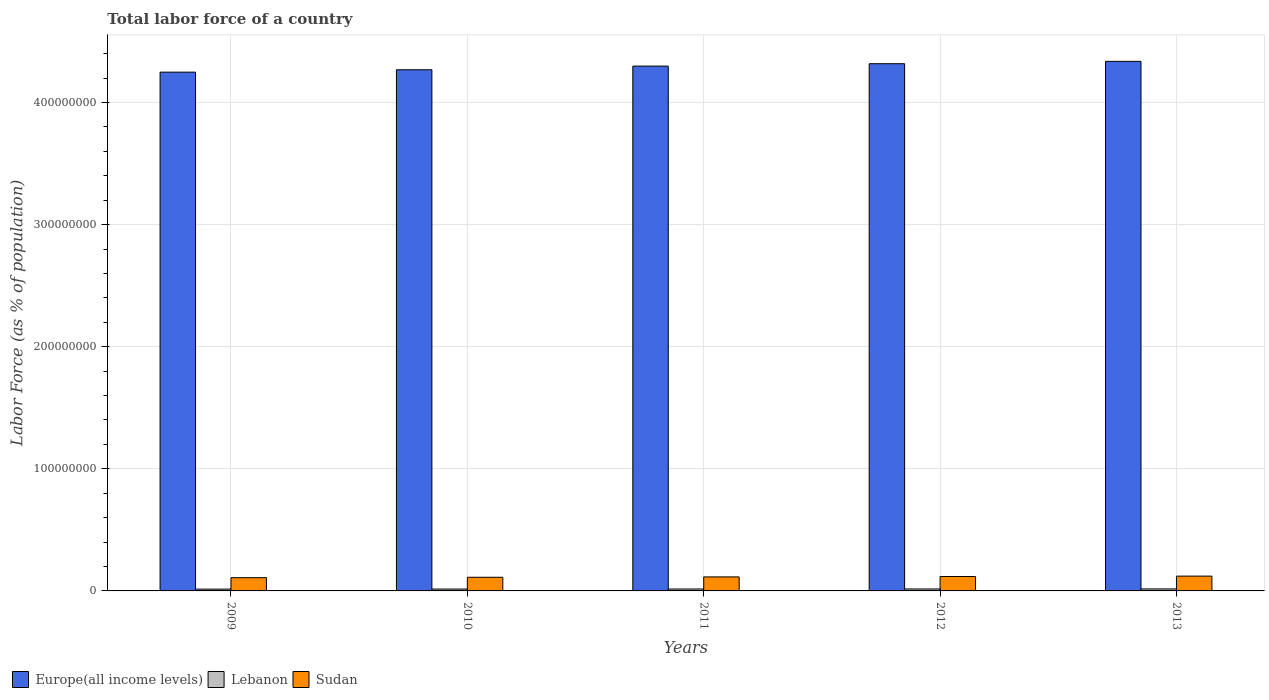Are the number of bars per tick equal to the number of legend labels?
Make the answer very short. Yes. What is the percentage of labor force in Lebanon in 2011?
Provide a short and direct response. 1.57e+06. Across all years, what is the maximum percentage of labor force in Europe(all income levels)?
Offer a very short reply. 4.34e+08. Across all years, what is the minimum percentage of labor force in Sudan?
Provide a short and direct response. 1.08e+07. What is the total percentage of labor force in Europe(all income levels) in the graph?
Offer a very short reply. 2.15e+09. What is the difference between the percentage of labor force in Sudan in 2009 and that in 2010?
Keep it short and to the point. -3.29e+05. What is the difference between the percentage of labor force in Sudan in 2010 and the percentage of labor force in Lebanon in 2012?
Your answer should be compact. 9.58e+06. What is the average percentage of labor force in Sudan per year?
Your response must be concise. 1.15e+07. In the year 2012, what is the difference between the percentage of labor force in Sudan and percentage of labor force in Europe(all income levels)?
Provide a succinct answer. -4.20e+08. What is the ratio of the percentage of labor force in Lebanon in 2012 to that in 2013?
Your answer should be very brief. 0.98. Is the percentage of labor force in Sudan in 2010 less than that in 2013?
Your answer should be compact. Yes. Is the difference between the percentage of labor force in Sudan in 2009 and 2012 greater than the difference between the percentage of labor force in Europe(all income levels) in 2009 and 2012?
Offer a very short reply. Yes. What is the difference between the highest and the second highest percentage of labor force in Sudan?
Ensure brevity in your answer.  3.13e+05. What is the difference between the highest and the lowest percentage of labor force in Europe(all income levels)?
Provide a short and direct response. 8.85e+06. In how many years, is the percentage of labor force in Lebanon greater than the average percentage of labor force in Lebanon taken over all years?
Provide a short and direct response. 3. What does the 3rd bar from the left in 2011 represents?
Provide a succinct answer. Sudan. What does the 3rd bar from the right in 2012 represents?
Offer a terse response. Europe(all income levels). Are all the bars in the graph horizontal?
Offer a very short reply. No. How many years are there in the graph?
Make the answer very short. 5. What is the difference between two consecutive major ticks on the Y-axis?
Offer a very short reply. 1.00e+08. Does the graph contain grids?
Give a very brief answer. Yes. How many legend labels are there?
Provide a short and direct response. 3. How are the legend labels stacked?
Provide a succinct answer. Horizontal. What is the title of the graph?
Offer a very short reply. Total labor force of a country. Does "Afghanistan" appear as one of the legend labels in the graph?
Make the answer very short. No. What is the label or title of the X-axis?
Provide a short and direct response. Years. What is the label or title of the Y-axis?
Give a very brief answer. Labor Force (as % of population). What is the Labor Force (as % of population) in Europe(all income levels) in 2009?
Provide a succinct answer. 4.25e+08. What is the Labor Force (as % of population) of Lebanon in 2009?
Your response must be concise. 1.47e+06. What is the Labor Force (as % of population) in Sudan in 2009?
Your response must be concise. 1.08e+07. What is the Labor Force (as % of population) of Europe(all income levels) in 2010?
Keep it short and to the point. 4.27e+08. What is the Labor Force (as % of population) of Lebanon in 2010?
Offer a terse response. 1.54e+06. What is the Labor Force (as % of population) of Sudan in 2010?
Your answer should be compact. 1.12e+07. What is the Labor Force (as % of population) in Europe(all income levels) in 2011?
Provide a succinct answer. 4.30e+08. What is the Labor Force (as % of population) of Lebanon in 2011?
Offer a terse response. 1.57e+06. What is the Labor Force (as % of population) in Sudan in 2011?
Offer a very short reply. 1.15e+07. What is the Labor Force (as % of population) in Europe(all income levels) in 2012?
Provide a short and direct response. 4.32e+08. What is the Labor Force (as % of population) in Lebanon in 2012?
Provide a succinct answer. 1.60e+06. What is the Labor Force (as % of population) in Sudan in 2012?
Your answer should be compact. 1.18e+07. What is the Labor Force (as % of population) in Europe(all income levels) in 2013?
Give a very brief answer. 4.34e+08. What is the Labor Force (as % of population) of Lebanon in 2013?
Offer a terse response. 1.63e+06. What is the Labor Force (as % of population) of Sudan in 2013?
Ensure brevity in your answer.  1.21e+07. Across all years, what is the maximum Labor Force (as % of population) of Europe(all income levels)?
Offer a very short reply. 4.34e+08. Across all years, what is the maximum Labor Force (as % of population) of Lebanon?
Give a very brief answer. 1.63e+06. Across all years, what is the maximum Labor Force (as % of population) of Sudan?
Your answer should be very brief. 1.21e+07. Across all years, what is the minimum Labor Force (as % of population) in Europe(all income levels)?
Offer a very short reply. 4.25e+08. Across all years, what is the minimum Labor Force (as % of population) of Lebanon?
Provide a succinct answer. 1.47e+06. Across all years, what is the minimum Labor Force (as % of population) in Sudan?
Offer a very short reply. 1.08e+07. What is the total Labor Force (as % of population) of Europe(all income levels) in the graph?
Keep it short and to the point. 2.15e+09. What is the total Labor Force (as % of population) in Lebanon in the graph?
Offer a very short reply. 7.81e+06. What is the total Labor Force (as % of population) in Sudan in the graph?
Ensure brevity in your answer.  5.74e+07. What is the difference between the Labor Force (as % of population) of Europe(all income levels) in 2009 and that in 2010?
Your answer should be very brief. -1.97e+06. What is the difference between the Labor Force (as % of population) in Lebanon in 2009 and that in 2010?
Your answer should be compact. -7.42e+04. What is the difference between the Labor Force (as % of population) of Sudan in 2009 and that in 2010?
Offer a terse response. -3.29e+05. What is the difference between the Labor Force (as % of population) in Europe(all income levels) in 2009 and that in 2011?
Provide a short and direct response. -4.95e+06. What is the difference between the Labor Force (as % of population) in Lebanon in 2009 and that in 2011?
Your answer should be very brief. -1.01e+05. What is the difference between the Labor Force (as % of population) of Sudan in 2009 and that in 2011?
Give a very brief answer. -6.33e+05. What is the difference between the Labor Force (as % of population) in Europe(all income levels) in 2009 and that in 2012?
Make the answer very short. -6.92e+06. What is the difference between the Labor Force (as % of population) of Lebanon in 2009 and that in 2012?
Give a very brief answer. -1.28e+05. What is the difference between the Labor Force (as % of population) in Sudan in 2009 and that in 2012?
Keep it short and to the point. -9.60e+05. What is the difference between the Labor Force (as % of population) in Europe(all income levels) in 2009 and that in 2013?
Your response must be concise. -8.85e+06. What is the difference between the Labor Force (as % of population) of Lebanon in 2009 and that in 2013?
Give a very brief answer. -1.57e+05. What is the difference between the Labor Force (as % of population) in Sudan in 2009 and that in 2013?
Ensure brevity in your answer.  -1.27e+06. What is the difference between the Labor Force (as % of population) in Europe(all income levels) in 2010 and that in 2011?
Provide a succinct answer. -2.99e+06. What is the difference between the Labor Force (as % of population) of Lebanon in 2010 and that in 2011?
Ensure brevity in your answer.  -2.70e+04. What is the difference between the Labor Force (as % of population) of Sudan in 2010 and that in 2011?
Ensure brevity in your answer.  -3.04e+05. What is the difference between the Labor Force (as % of population) in Europe(all income levels) in 2010 and that in 2012?
Make the answer very short. -4.95e+06. What is the difference between the Labor Force (as % of population) of Lebanon in 2010 and that in 2012?
Make the answer very short. -5.42e+04. What is the difference between the Labor Force (as % of population) of Sudan in 2010 and that in 2012?
Give a very brief answer. -6.31e+05. What is the difference between the Labor Force (as % of population) in Europe(all income levels) in 2010 and that in 2013?
Your response must be concise. -6.88e+06. What is the difference between the Labor Force (as % of population) in Lebanon in 2010 and that in 2013?
Your answer should be compact. -8.25e+04. What is the difference between the Labor Force (as % of population) in Sudan in 2010 and that in 2013?
Offer a terse response. -9.44e+05. What is the difference between the Labor Force (as % of population) of Europe(all income levels) in 2011 and that in 2012?
Provide a succinct answer. -1.97e+06. What is the difference between the Labor Force (as % of population) of Lebanon in 2011 and that in 2012?
Offer a terse response. -2.72e+04. What is the difference between the Labor Force (as % of population) of Sudan in 2011 and that in 2012?
Your response must be concise. -3.27e+05. What is the difference between the Labor Force (as % of population) of Europe(all income levels) in 2011 and that in 2013?
Provide a short and direct response. -3.89e+06. What is the difference between the Labor Force (as % of population) in Lebanon in 2011 and that in 2013?
Keep it short and to the point. -5.56e+04. What is the difference between the Labor Force (as % of population) in Sudan in 2011 and that in 2013?
Your response must be concise. -6.40e+05. What is the difference between the Labor Force (as % of population) in Europe(all income levels) in 2012 and that in 2013?
Ensure brevity in your answer.  -1.93e+06. What is the difference between the Labor Force (as % of population) in Lebanon in 2012 and that in 2013?
Ensure brevity in your answer.  -2.84e+04. What is the difference between the Labor Force (as % of population) of Sudan in 2012 and that in 2013?
Offer a very short reply. -3.13e+05. What is the difference between the Labor Force (as % of population) in Europe(all income levels) in 2009 and the Labor Force (as % of population) in Lebanon in 2010?
Offer a terse response. 4.23e+08. What is the difference between the Labor Force (as % of population) of Europe(all income levels) in 2009 and the Labor Force (as % of population) of Sudan in 2010?
Your answer should be very brief. 4.14e+08. What is the difference between the Labor Force (as % of population) of Lebanon in 2009 and the Labor Force (as % of population) of Sudan in 2010?
Make the answer very short. -9.70e+06. What is the difference between the Labor Force (as % of population) in Europe(all income levels) in 2009 and the Labor Force (as % of population) in Lebanon in 2011?
Keep it short and to the point. 4.23e+08. What is the difference between the Labor Force (as % of population) of Europe(all income levels) in 2009 and the Labor Force (as % of population) of Sudan in 2011?
Your response must be concise. 4.13e+08. What is the difference between the Labor Force (as % of population) in Lebanon in 2009 and the Labor Force (as % of population) in Sudan in 2011?
Your answer should be very brief. -1.00e+07. What is the difference between the Labor Force (as % of population) in Europe(all income levels) in 2009 and the Labor Force (as % of population) in Lebanon in 2012?
Give a very brief answer. 4.23e+08. What is the difference between the Labor Force (as % of population) of Europe(all income levels) in 2009 and the Labor Force (as % of population) of Sudan in 2012?
Provide a succinct answer. 4.13e+08. What is the difference between the Labor Force (as % of population) of Lebanon in 2009 and the Labor Force (as % of population) of Sudan in 2012?
Provide a short and direct response. -1.03e+07. What is the difference between the Labor Force (as % of population) of Europe(all income levels) in 2009 and the Labor Force (as % of population) of Lebanon in 2013?
Offer a terse response. 4.23e+08. What is the difference between the Labor Force (as % of population) of Europe(all income levels) in 2009 and the Labor Force (as % of population) of Sudan in 2013?
Offer a very short reply. 4.13e+08. What is the difference between the Labor Force (as % of population) of Lebanon in 2009 and the Labor Force (as % of population) of Sudan in 2013?
Offer a very short reply. -1.06e+07. What is the difference between the Labor Force (as % of population) in Europe(all income levels) in 2010 and the Labor Force (as % of population) in Lebanon in 2011?
Offer a very short reply. 4.25e+08. What is the difference between the Labor Force (as % of population) in Europe(all income levels) in 2010 and the Labor Force (as % of population) in Sudan in 2011?
Your answer should be compact. 4.15e+08. What is the difference between the Labor Force (as % of population) of Lebanon in 2010 and the Labor Force (as % of population) of Sudan in 2011?
Make the answer very short. -9.93e+06. What is the difference between the Labor Force (as % of population) in Europe(all income levels) in 2010 and the Labor Force (as % of population) in Lebanon in 2012?
Ensure brevity in your answer.  4.25e+08. What is the difference between the Labor Force (as % of population) of Europe(all income levels) in 2010 and the Labor Force (as % of population) of Sudan in 2012?
Your answer should be compact. 4.15e+08. What is the difference between the Labor Force (as % of population) in Lebanon in 2010 and the Labor Force (as % of population) in Sudan in 2012?
Provide a succinct answer. -1.03e+07. What is the difference between the Labor Force (as % of population) in Europe(all income levels) in 2010 and the Labor Force (as % of population) in Lebanon in 2013?
Give a very brief answer. 4.25e+08. What is the difference between the Labor Force (as % of population) of Europe(all income levels) in 2010 and the Labor Force (as % of population) of Sudan in 2013?
Give a very brief answer. 4.15e+08. What is the difference between the Labor Force (as % of population) of Lebanon in 2010 and the Labor Force (as % of population) of Sudan in 2013?
Give a very brief answer. -1.06e+07. What is the difference between the Labor Force (as % of population) of Europe(all income levels) in 2011 and the Labor Force (as % of population) of Lebanon in 2012?
Your answer should be compact. 4.28e+08. What is the difference between the Labor Force (as % of population) of Europe(all income levels) in 2011 and the Labor Force (as % of population) of Sudan in 2012?
Give a very brief answer. 4.18e+08. What is the difference between the Labor Force (as % of population) in Lebanon in 2011 and the Labor Force (as % of population) in Sudan in 2012?
Make the answer very short. -1.02e+07. What is the difference between the Labor Force (as % of population) of Europe(all income levels) in 2011 and the Labor Force (as % of population) of Lebanon in 2013?
Keep it short and to the point. 4.28e+08. What is the difference between the Labor Force (as % of population) in Europe(all income levels) in 2011 and the Labor Force (as % of population) in Sudan in 2013?
Your response must be concise. 4.18e+08. What is the difference between the Labor Force (as % of population) of Lebanon in 2011 and the Labor Force (as % of population) of Sudan in 2013?
Offer a very short reply. -1.05e+07. What is the difference between the Labor Force (as % of population) of Europe(all income levels) in 2012 and the Labor Force (as % of population) of Lebanon in 2013?
Your answer should be very brief. 4.30e+08. What is the difference between the Labor Force (as % of population) in Europe(all income levels) in 2012 and the Labor Force (as % of population) in Sudan in 2013?
Your response must be concise. 4.20e+08. What is the difference between the Labor Force (as % of population) in Lebanon in 2012 and the Labor Force (as % of population) in Sudan in 2013?
Make the answer very short. -1.05e+07. What is the average Labor Force (as % of population) in Europe(all income levels) per year?
Offer a terse response. 4.29e+08. What is the average Labor Force (as % of population) in Lebanon per year?
Provide a succinct answer. 1.56e+06. What is the average Labor Force (as % of population) of Sudan per year?
Ensure brevity in your answer.  1.15e+07. In the year 2009, what is the difference between the Labor Force (as % of population) of Europe(all income levels) and Labor Force (as % of population) of Lebanon?
Make the answer very short. 4.23e+08. In the year 2009, what is the difference between the Labor Force (as % of population) of Europe(all income levels) and Labor Force (as % of population) of Sudan?
Make the answer very short. 4.14e+08. In the year 2009, what is the difference between the Labor Force (as % of population) of Lebanon and Labor Force (as % of population) of Sudan?
Keep it short and to the point. -9.38e+06. In the year 2010, what is the difference between the Labor Force (as % of population) in Europe(all income levels) and Labor Force (as % of population) in Lebanon?
Your answer should be very brief. 4.25e+08. In the year 2010, what is the difference between the Labor Force (as % of population) of Europe(all income levels) and Labor Force (as % of population) of Sudan?
Your response must be concise. 4.16e+08. In the year 2010, what is the difference between the Labor Force (as % of population) in Lebanon and Labor Force (as % of population) in Sudan?
Offer a terse response. -9.63e+06. In the year 2011, what is the difference between the Labor Force (as % of population) in Europe(all income levels) and Labor Force (as % of population) in Lebanon?
Provide a short and direct response. 4.28e+08. In the year 2011, what is the difference between the Labor Force (as % of population) in Europe(all income levels) and Labor Force (as % of population) in Sudan?
Your answer should be very brief. 4.18e+08. In the year 2011, what is the difference between the Labor Force (as % of population) in Lebanon and Labor Force (as % of population) in Sudan?
Provide a short and direct response. -9.91e+06. In the year 2012, what is the difference between the Labor Force (as % of population) of Europe(all income levels) and Labor Force (as % of population) of Lebanon?
Your answer should be very brief. 4.30e+08. In the year 2012, what is the difference between the Labor Force (as % of population) of Europe(all income levels) and Labor Force (as % of population) of Sudan?
Offer a terse response. 4.20e+08. In the year 2012, what is the difference between the Labor Force (as % of population) in Lebanon and Labor Force (as % of population) in Sudan?
Provide a short and direct response. -1.02e+07. In the year 2013, what is the difference between the Labor Force (as % of population) in Europe(all income levels) and Labor Force (as % of population) in Lebanon?
Make the answer very short. 4.32e+08. In the year 2013, what is the difference between the Labor Force (as % of population) of Europe(all income levels) and Labor Force (as % of population) of Sudan?
Your response must be concise. 4.22e+08. In the year 2013, what is the difference between the Labor Force (as % of population) of Lebanon and Labor Force (as % of population) of Sudan?
Offer a terse response. -1.05e+07. What is the ratio of the Labor Force (as % of population) of Sudan in 2009 to that in 2010?
Offer a very short reply. 0.97. What is the ratio of the Labor Force (as % of population) of Lebanon in 2009 to that in 2011?
Your answer should be compact. 0.94. What is the ratio of the Labor Force (as % of population) in Sudan in 2009 to that in 2011?
Provide a succinct answer. 0.94. What is the ratio of the Labor Force (as % of population) in Europe(all income levels) in 2009 to that in 2012?
Ensure brevity in your answer.  0.98. What is the ratio of the Labor Force (as % of population) in Lebanon in 2009 to that in 2012?
Offer a very short reply. 0.92. What is the ratio of the Labor Force (as % of population) in Sudan in 2009 to that in 2012?
Provide a succinct answer. 0.92. What is the ratio of the Labor Force (as % of population) of Europe(all income levels) in 2009 to that in 2013?
Ensure brevity in your answer.  0.98. What is the ratio of the Labor Force (as % of population) in Lebanon in 2009 to that in 2013?
Offer a very short reply. 0.9. What is the ratio of the Labor Force (as % of population) of Sudan in 2009 to that in 2013?
Offer a terse response. 0.89. What is the ratio of the Labor Force (as % of population) of Lebanon in 2010 to that in 2011?
Your answer should be very brief. 0.98. What is the ratio of the Labor Force (as % of population) in Sudan in 2010 to that in 2011?
Your answer should be compact. 0.97. What is the ratio of the Labor Force (as % of population) in Europe(all income levels) in 2010 to that in 2012?
Give a very brief answer. 0.99. What is the ratio of the Labor Force (as % of population) of Lebanon in 2010 to that in 2012?
Give a very brief answer. 0.97. What is the ratio of the Labor Force (as % of population) in Sudan in 2010 to that in 2012?
Give a very brief answer. 0.95. What is the ratio of the Labor Force (as % of population) of Europe(all income levels) in 2010 to that in 2013?
Keep it short and to the point. 0.98. What is the ratio of the Labor Force (as % of population) of Lebanon in 2010 to that in 2013?
Provide a short and direct response. 0.95. What is the ratio of the Labor Force (as % of population) in Sudan in 2010 to that in 2013?
Your response must be concise. 0.92. What is the ratio of the Labor Force (as % of population) of Europe(all income levels) in 2011 to that in 2012?
Keep it short and to the point. 1. What is the ratio of the Labor Force (as % of population) of Lebanon in 2011 to that in 2012?
Ensure brevity in your answer.  0.98. What is the ratio of the Labor Force (as % of population) of Sudan in 2011 to that in 2012?
Make the answer very short. 0.97. What is the ratio of the Labor Force (as % of population) in Europe(all income levels) in 2011 to that in 2013?
Provide a short and direct response. 0.99. What is the ratio of the Labor Force (as % of population) of Lebanon in 2011 to that in 2013?
Offer a very short reply. 0.97. What is the ratio of the Labor Force (as % of population) in Sudan in 2011 to that in 2013?
Offer a very short reply. 0.95. What is the ratio of the Labor Force (as % of population) of Lebanon in 2012 to that in 2013?
Keep it short and to the point. 0.98. What is the ratio of the Labor Force (as % of population) of Sudan in 2012 to that in 2013?
Provide a succinct answer. 0.97. What is the difference between the highest and the second highest Labor Force (as % of population) of Europe(all income levels)?
Make the answer very short. 1.93e+06. What is the difference between the highest and the second highest Labor Force (as % of population) of Lebanon?
Keep it short and to the point. 2.84e+04. What is the difference between the highest and the second highest Labor Force (as % of population) of Sudan?
Your answer should be compact. 3.13e+05. What is the difference between the highest and the lowest Labor Force (as % of population) of Europe(all income levels)?
Offer a terse response. 8.85e+06. What is the difference between the highest and the lowest Labor Force (as % of population) in Lebanon?
Provide a succinct answer. 1.57e+05. What is the difference between the highest and the lowest Labor Force (as % of population) of Sudan?
Your response must be concise. 1.27e+06. 